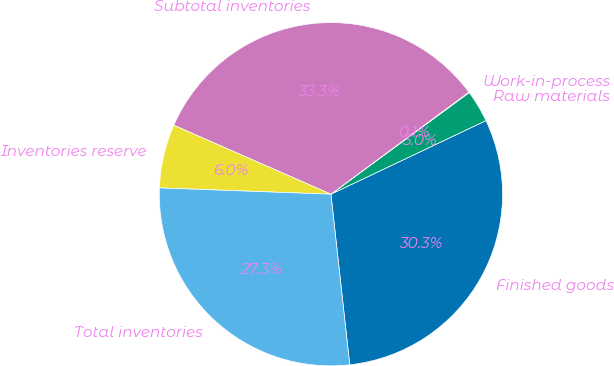Convert chart. <chart><loc_0><loc_0><loc_500><loc_500><pie_chart><fcel>Finished goods<fcel>Raw materials<fcel>Work-in-process<fcel>Subtotal inventories<fcel>Inventories reserve<fcel>Total inventories<nl><fcel>30.31%<fcel>3.03%<fcel>0.05%<fcel>33.28%<fcel>6.0%<fcel>27.33%<nl></chart> 